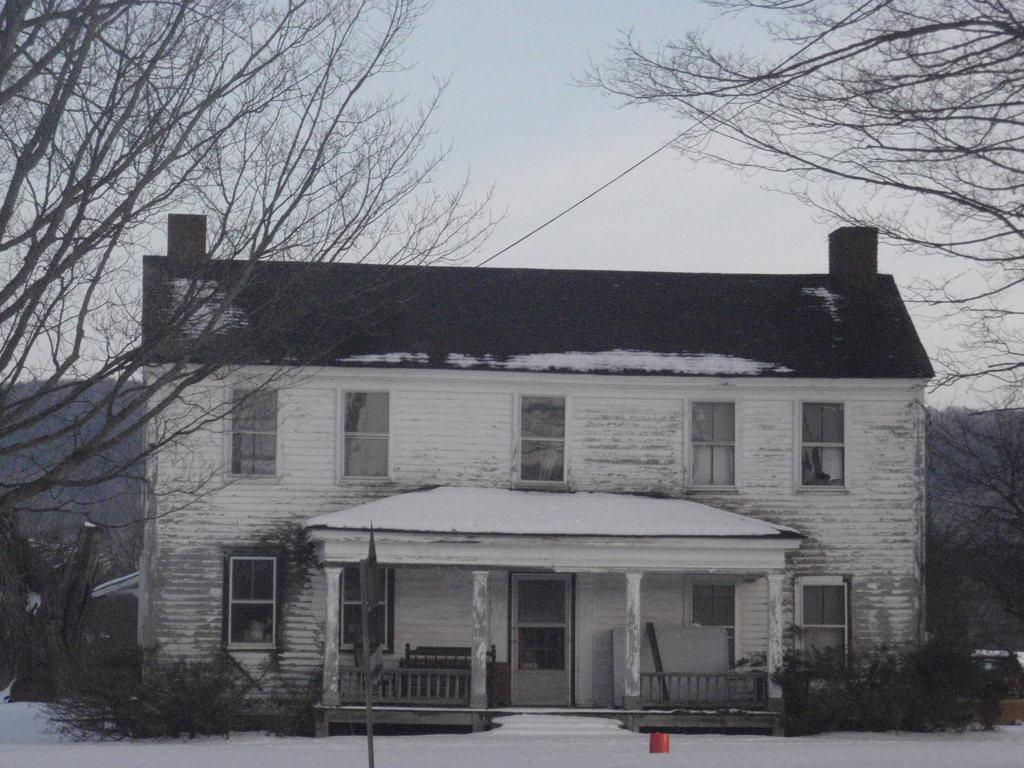What type of structure is present in the image? There is a building in the image. What features can be seen on the building? The building has windows, a door, and pillars. What is located near the building in the image? There is a fence in the image. What type of vegetation is present in the image? There are trees in the image. What can be seen in the background of the image? The sky is visible in the background of the image. How many wheels are attached to the basin in the image? There is no basin or wheel present in the image. 